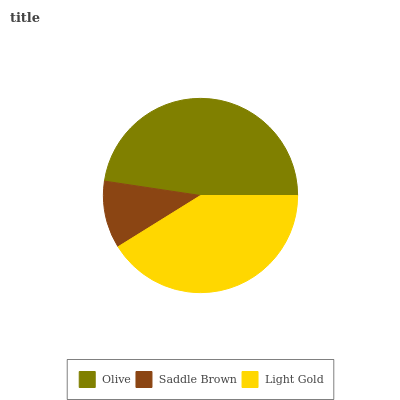Is Saddle Brown the minimum?
Answer yes or no. Yes. Is Olive the maximum?
Answer yes or no. Yes. Is Light Gold the minimum?
Answer yes or no. No. Is Light Gold the maximum?
Answer yes or no. No. Is Light Gold greater than Saddle Brown?
Answer yes or no. Yes. Is Saddle Brown less than Light Gold?
Answer yes or no. Yes. Is Saddle Brown greater than Light Gold?
Answer yes or no. No. Is Light Gold less than Saddle Brown?
Answer yes or no. No. Is Light Gold the high median?
Answer yes or no. Yes. Is Light Gold the low median?
Answer yes or no. Yes. Is Olive the high median?
Answer yes or no. No. Is Saddle Brown the low median?
Answer yes or no. No. 